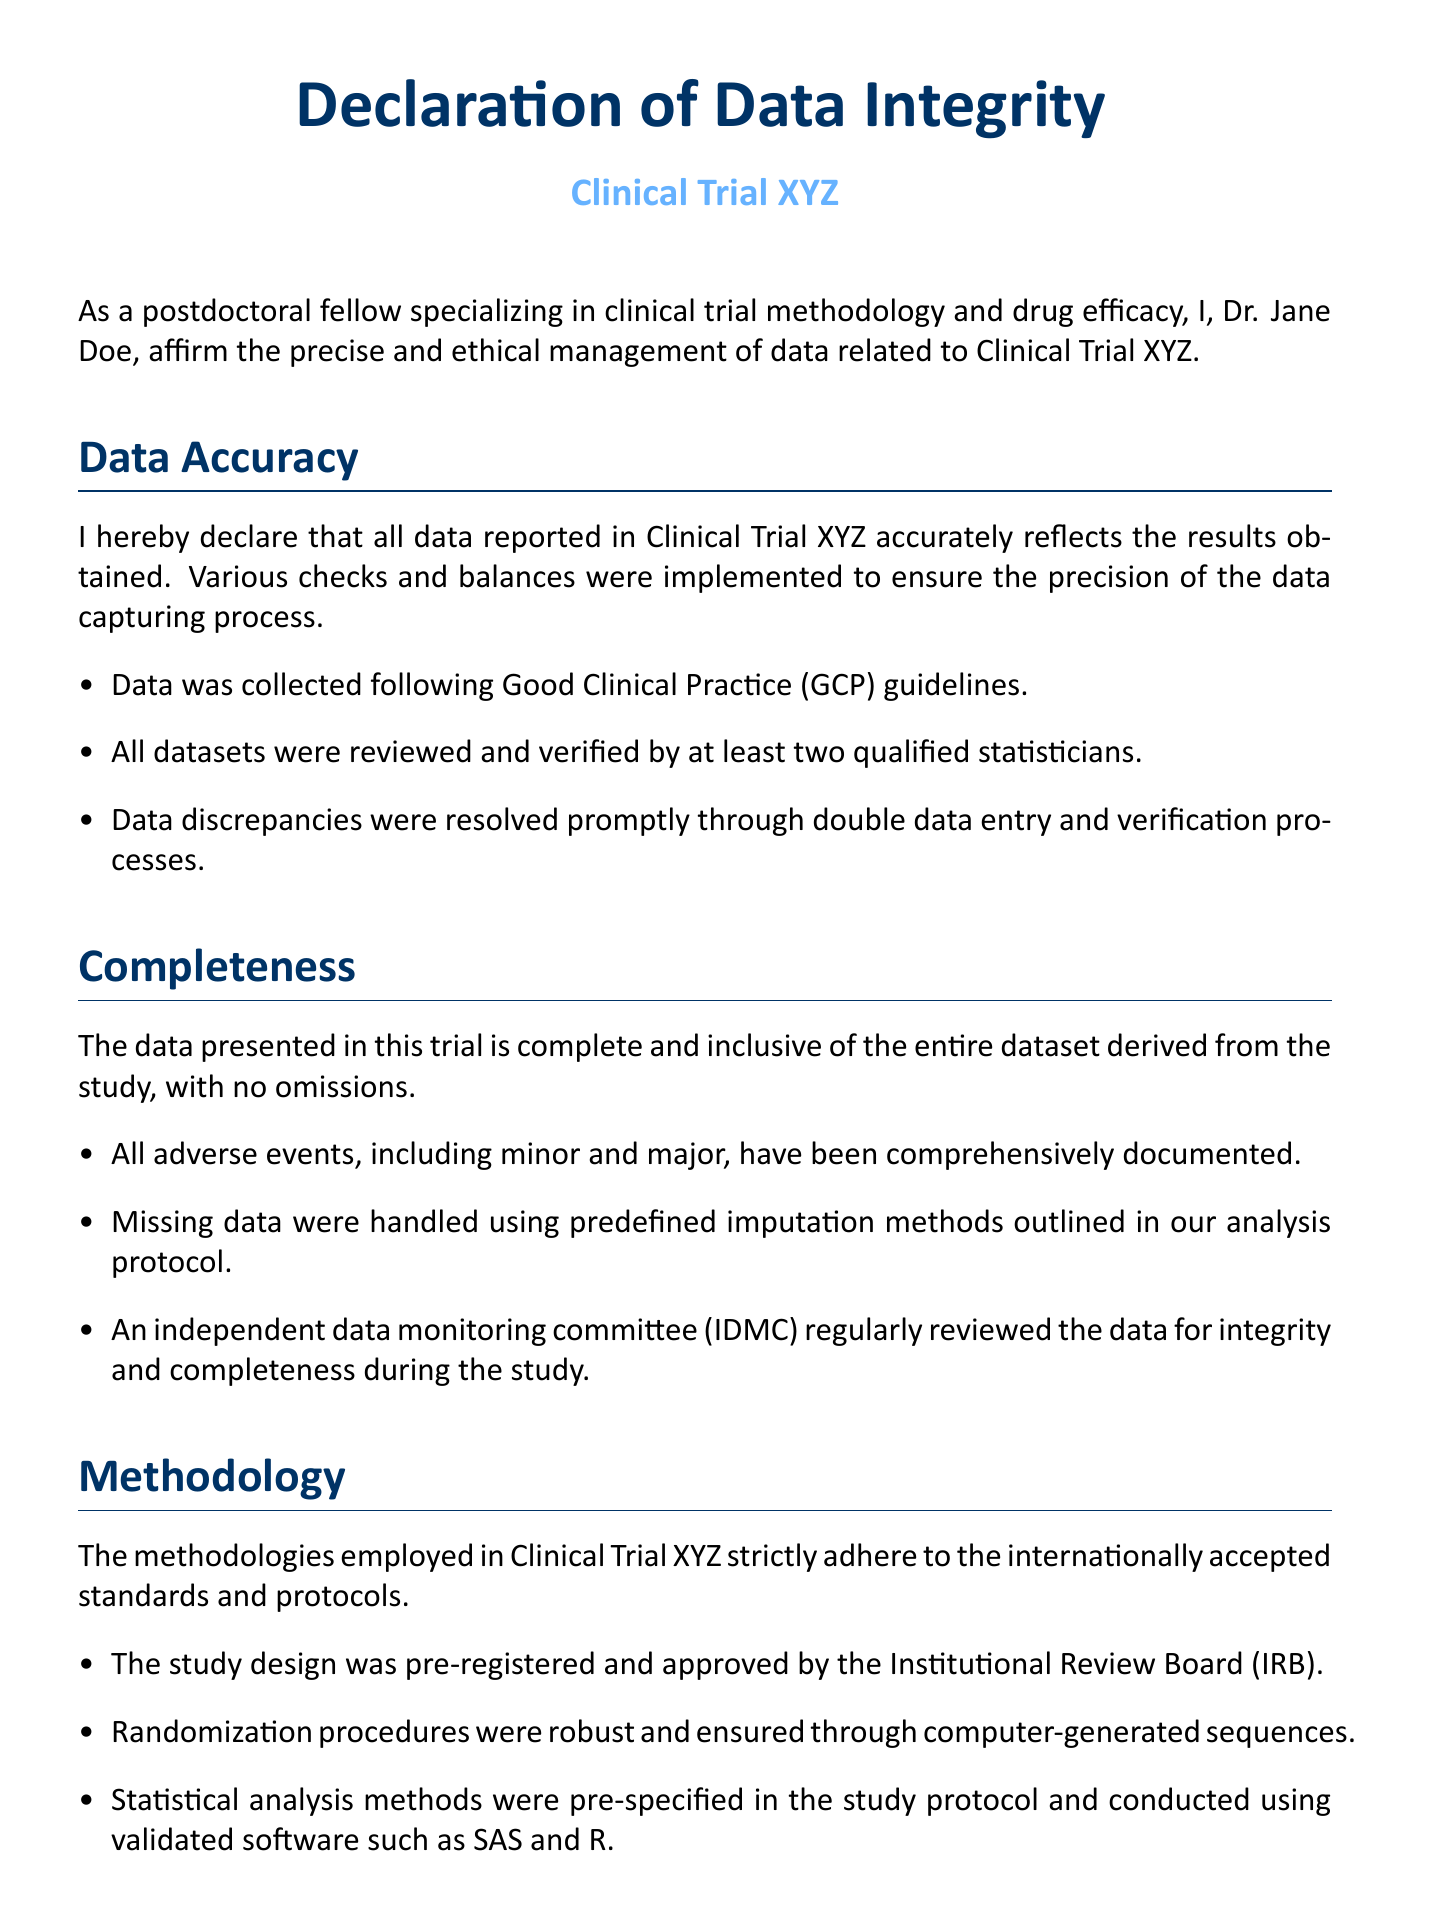What is the title of the document? The title of the document signifies its primary focus, which is the declaration concerning data integrity.
Answer: Declaration of Data Integrity Who is the author of the declaration? The author is the individual who is affirming the accuracy and completeness of the data in the study.
Answer: Dr. Jane Doe What is the participant's email address? This is a specific piece of contact information provided in the document.
Answer: jane.doe@researchinstitute.edu Which guidelines were followed for data collection? This refers to the regulations that govern proper clinical trial practices and data management.
Answer: Good Clinical Practice (GCP) What committee reviewed data integrity during the study? This committee is responsible for overseeing the ethical collection and integrity of data.
Answer: independent data monitoring committee (IDMC) How many statisticians reviewed the datasets? This number pertains to the verification process of data in the study.
Answer: at least two What software was used for statistical analysis? This refers to the validated software mentioned for conducting statistical analyses in the trial.
Answer: SAS and R Was the study design pre-registered? This addresses whether the study was documented prior to initiation, a key factor in research transparency.
Answer: Yes What is the significance of the Institutional Review Board? This board ensures that research is conducted ethically and adheres to established standards.
Answer: Approved the study design 